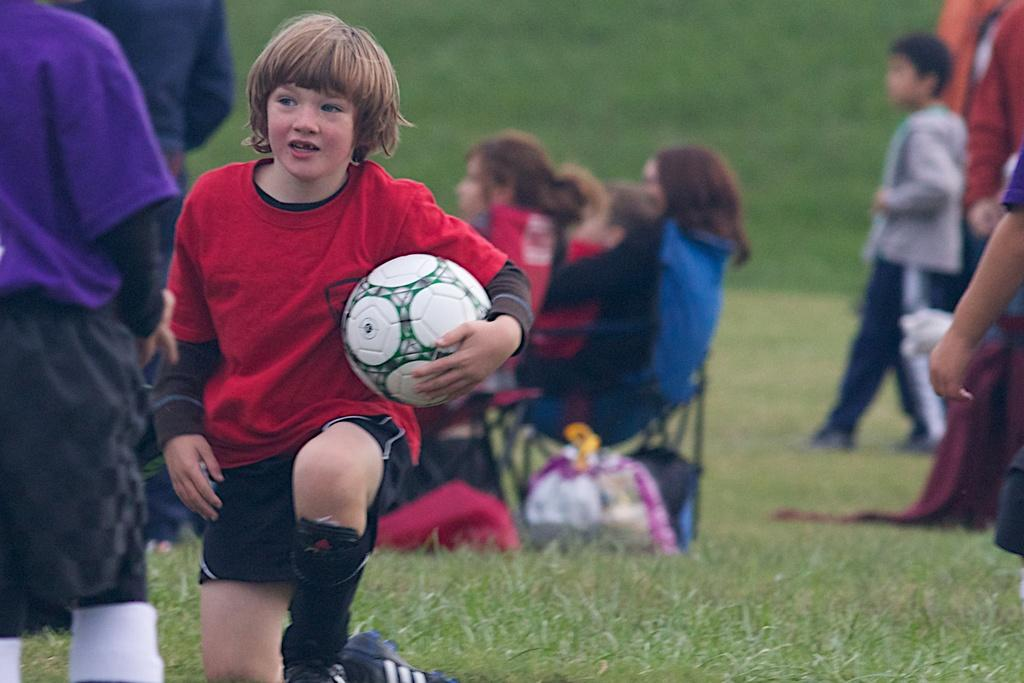What is the boy in the image doing? The boy is sitting in the image. What is the boy holding in his hand? The boy is holding a ball in his hand. Can you describe the people in the image? There is a group of persons standing and a group of people sitting in the image. What type of surface is visible in the image? There is grass visible in the image. What type of spring activity is the boy participating in the image? There is no specific spring activity mentioned or depicted in the image. Can you see any screws in the image? There are no screws visible in the image. 